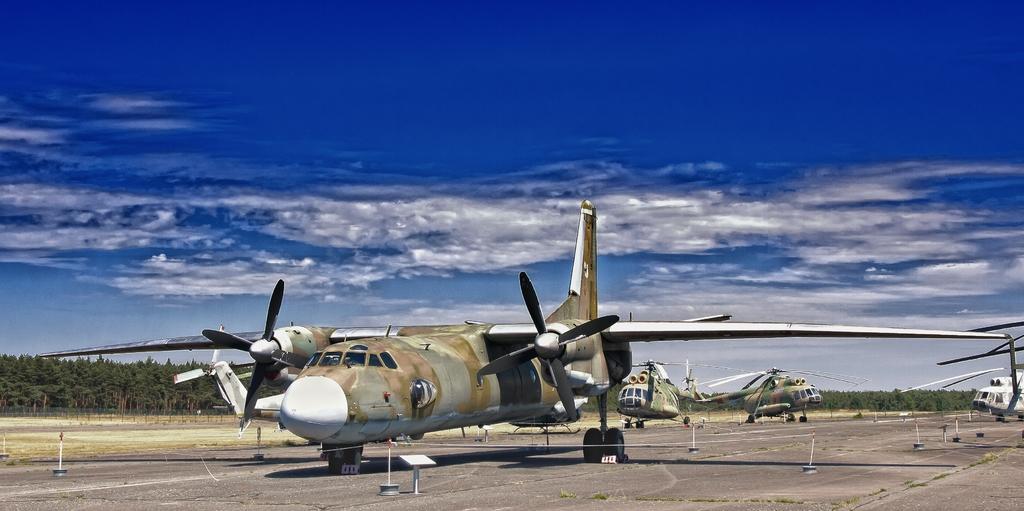Can you describe this image briefly? In this image we can see the airplane and also helicopters on the runway. We can also see the land and also many trees. In the background there is sky with some clouds. 